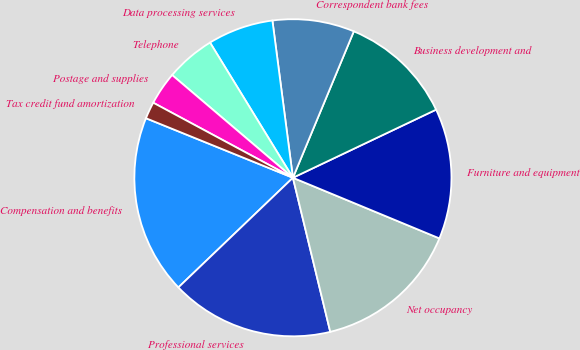<chart> <loc_0><loc_0><loc_500><loc_500><pie_chart><fcel>Compensation and benefits<fcel>Professional services<fcel>Net occupancy<fcel>Furniture and equipment<fcel>Business development and<fcel>Correspondent bank fees<fcel>Data processing services<fcel>Telephone<fcel>Postage and supplies<fcel>Tax credit fund amortization<nl><fcel>18.28%<fcel>16.63%<fcel>14.97%<fcel>13.31%<fcel>11.66%<fcel>8.34%<fcel>6.69%<fcel>5.03%<fcel>3.37%<fcel>1.72%<nl></chart> 